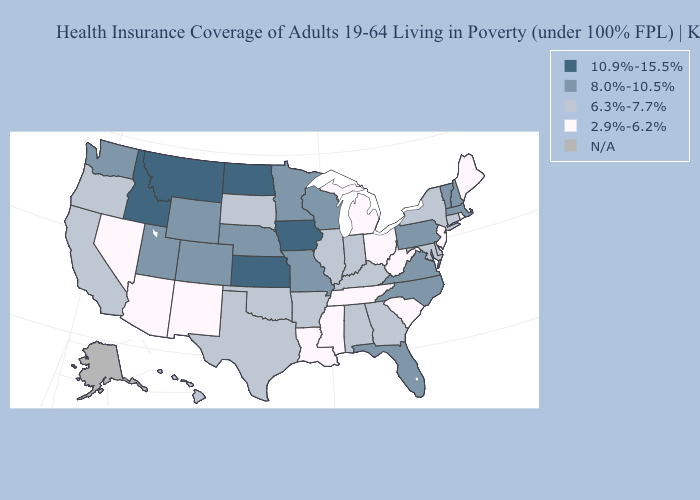Name the states that have a value in the range 6.3%-7.7%?
Answer briefly. Alabama, Arkansas, California, Connecticut, Delaware, Georgia, Hawaii, Illinois, Indiana, Kentucky, Maryland, New York, Oklahoma, Oregon, South Dakota, Texas. Does New Jersey have the highest value in the Northeast?
Be succinct. No. What is the value of Idaho?
Write a very short answer. 10.9%-15.5%. Name the states that have a value in the range 6.3%-7.7%?
Give a very brief answer. Alabama, Arkansas, California, Connecticut, Delaware, Georgia, Hawaii, Illinois, Indiana, Kentucky, Maryland, New York, Oklahoma, Oregon, South Dakota, Texas. Does Louisiana have the lowest value in the USA?
Give a very brief answer. Yes. Name the states that have a value in the range 10.9%-15.5%?
Short answer required. Idaho, Iowa, Kansas, Montana, North Dakota. How many symbols are there in the legend?
Short answer required. 5. What is the lowest value in the West?
Keep it brief. 2.9%-6.2%. Which states have the lowest value in the Northeast?
Give a very brief answer. Maine, New Jersey, Rhode Island. Among the states that border Idaho , which have the lowest value?
Quick response, please. Nevada. What is the value of Mississippi?
Answer briefly. 2.9%-6.2%. Which states hav the highest value in the West?
Keep it brief. Idaho, Montana. What is the highest value in the West ?
Give a very brief answer. 10.9%-15.5%. What is the lowest value in the USA?
Quick response, please. 2.9%-6.2%. 